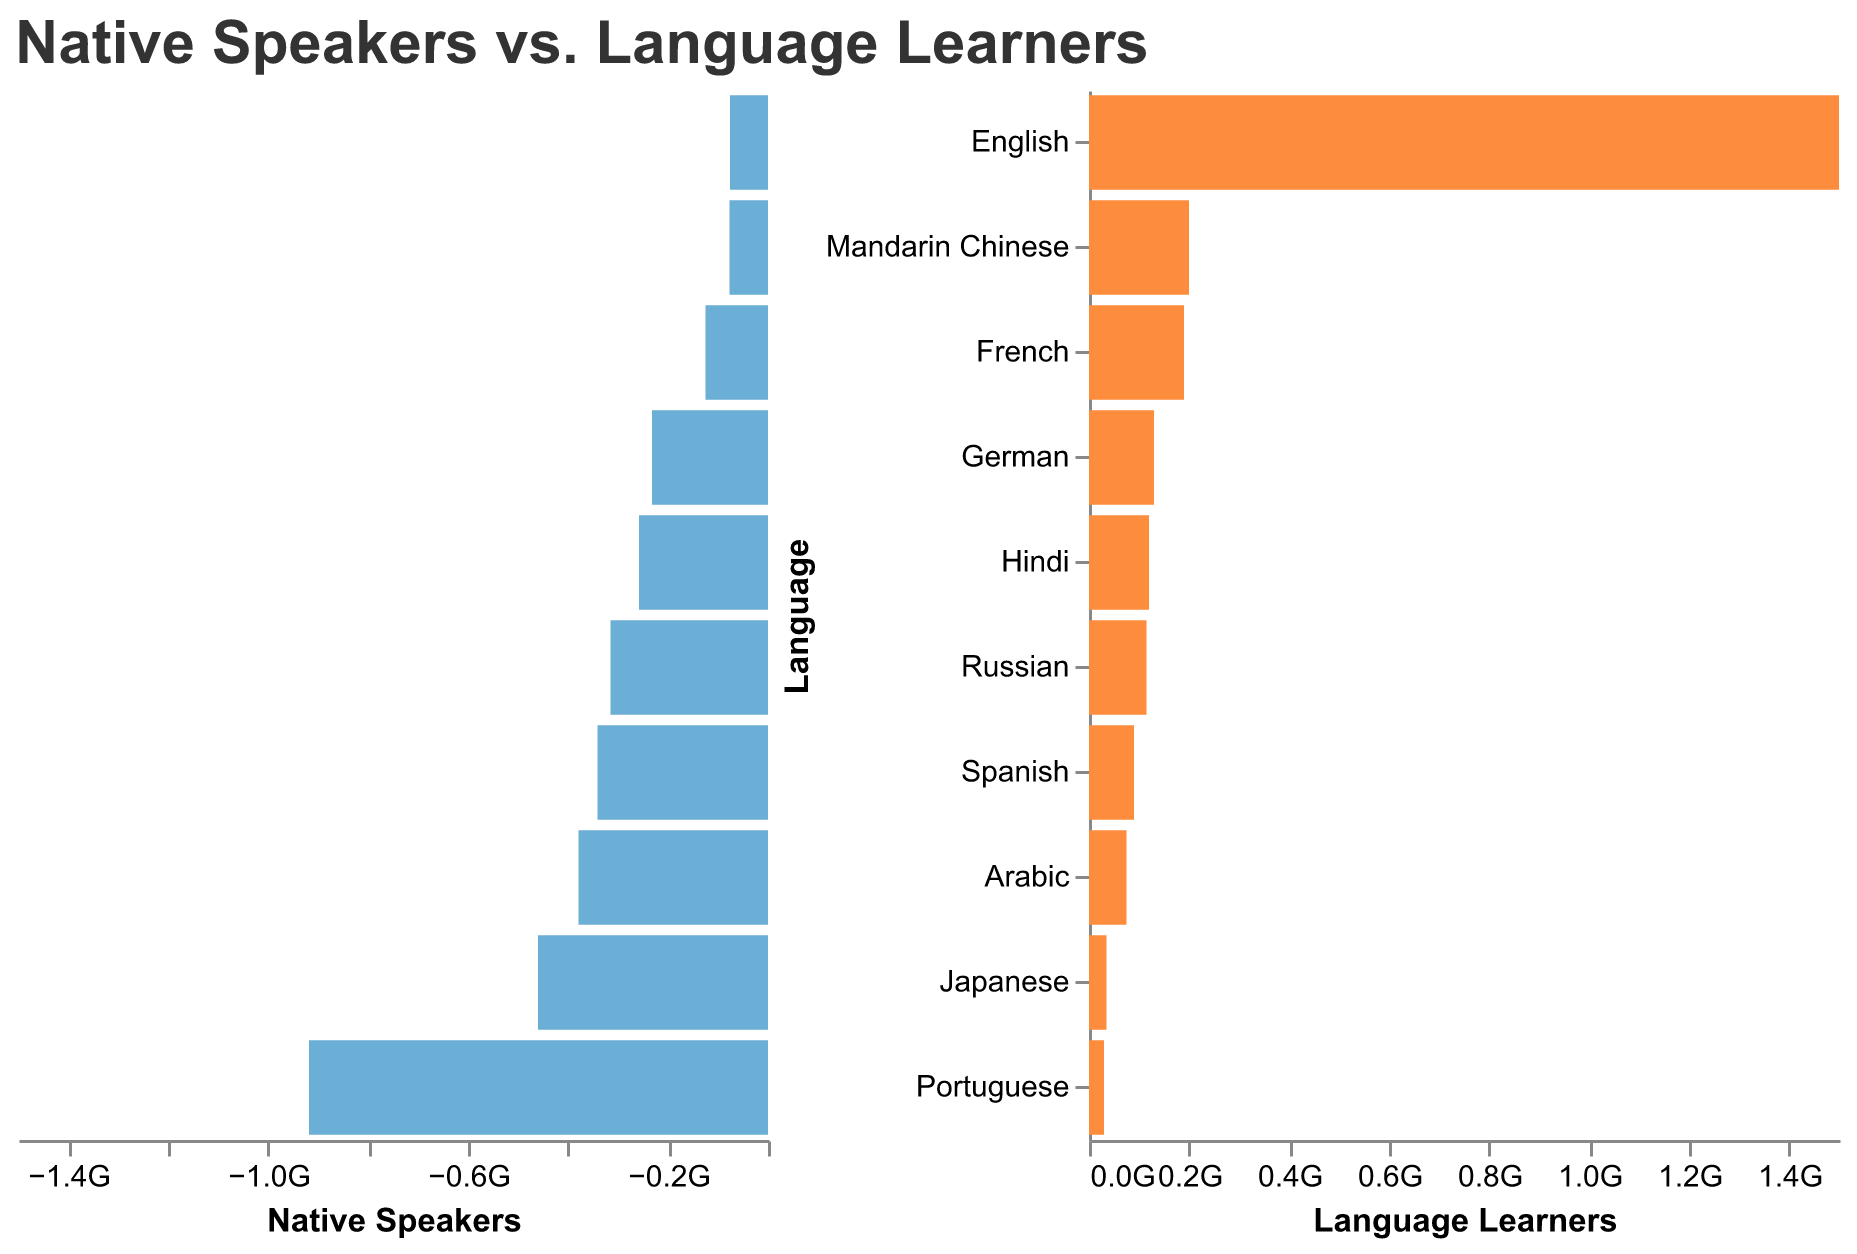What is the total number of native speakers for Mandarin Chinese and Spanish? The figure shows native speakers for Mandarin Chinese as 918 million and for Spanish as 460 million. Adding these numbers: 918,000,000 + 460,000,000 = 1,378,000,000
Answer: 1,378,000,000 Which language has the highest number of language learners? The right side of the figure shows that English has the highest number of language learners at 1,500,000,000.
Answer: English How many more language learners does English have compared to Mandarin Chinese? The figure shows that English has 1,500,000,000 language learners, while Mandarin Chinese has 200,000,000. Subtracting the latter from the former: 1,500,000,000 - 200,000,000 = 1,300,000,000
Answer: 1,300,000,000 Is there any language that has more language learners than native speakers? By comparing the two sides of the figure, we can see that English (379 million native speakers and 1.5 billion language learners), French (77 million native speakers and 190 million language learners), and German (76 million native speakers and 130 million language learners) meet this criteria.
Answer: Yes (English, French, and German) What percentage of Hindi speakers are native speakers? Hindi has 341,000,000 native speakers and 120,000,000 language learners. The total number of speakers is 341,000,000 + 120,000,000 = 461,000,000. The percentage of native speakers is (341,000,000 / 461,000,000) * 100, which calculates to approximately 73.96%.
Answer: 73.96% Which language has the smallest number of language learners? By examining the right side of the figure, it's evident that Portuguese has the smallest number of language learners at 30,000,000.
Answer: Portuguese 